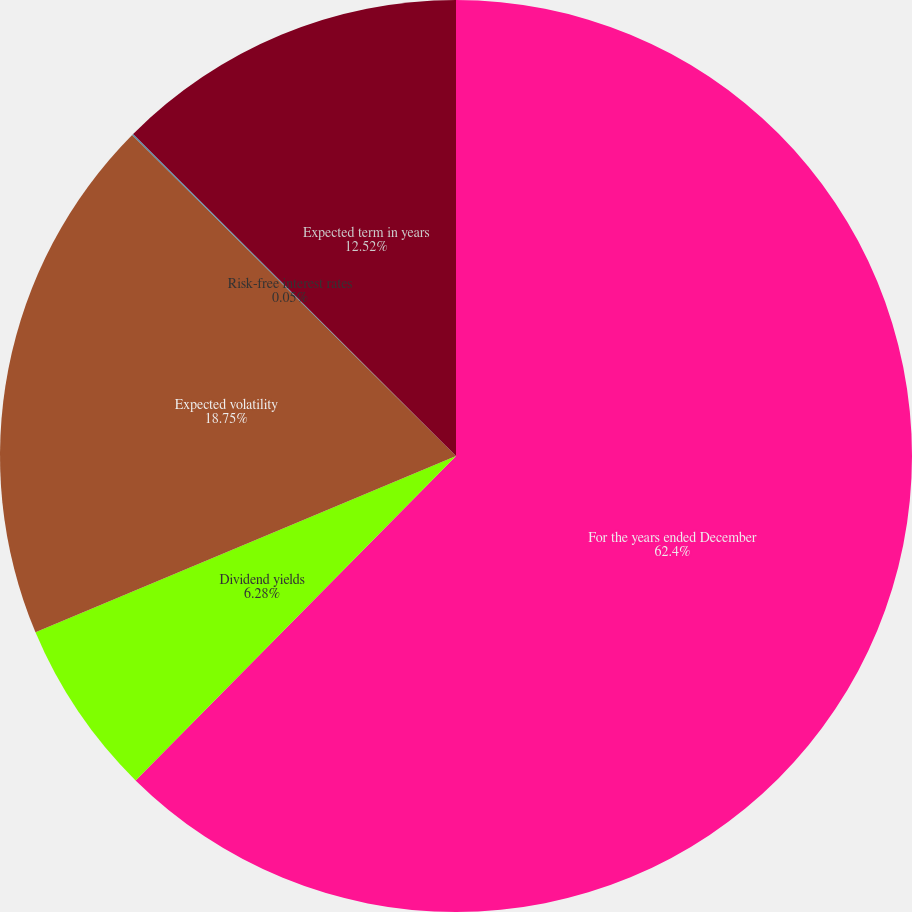<chart> <loc_0><loc_0><loc_500><loc_500><pie_chart><fcel>For the years ended December<fcel>Dividend yields<fcel>Expected volatility<fcel>Risk-free interest rates<fcel>Expected term in years<nl><fcel>62.4%<fcel>6.28%<fcel>18.75%<fcel>0.05%<fcel>12.52%<nl></chart> 